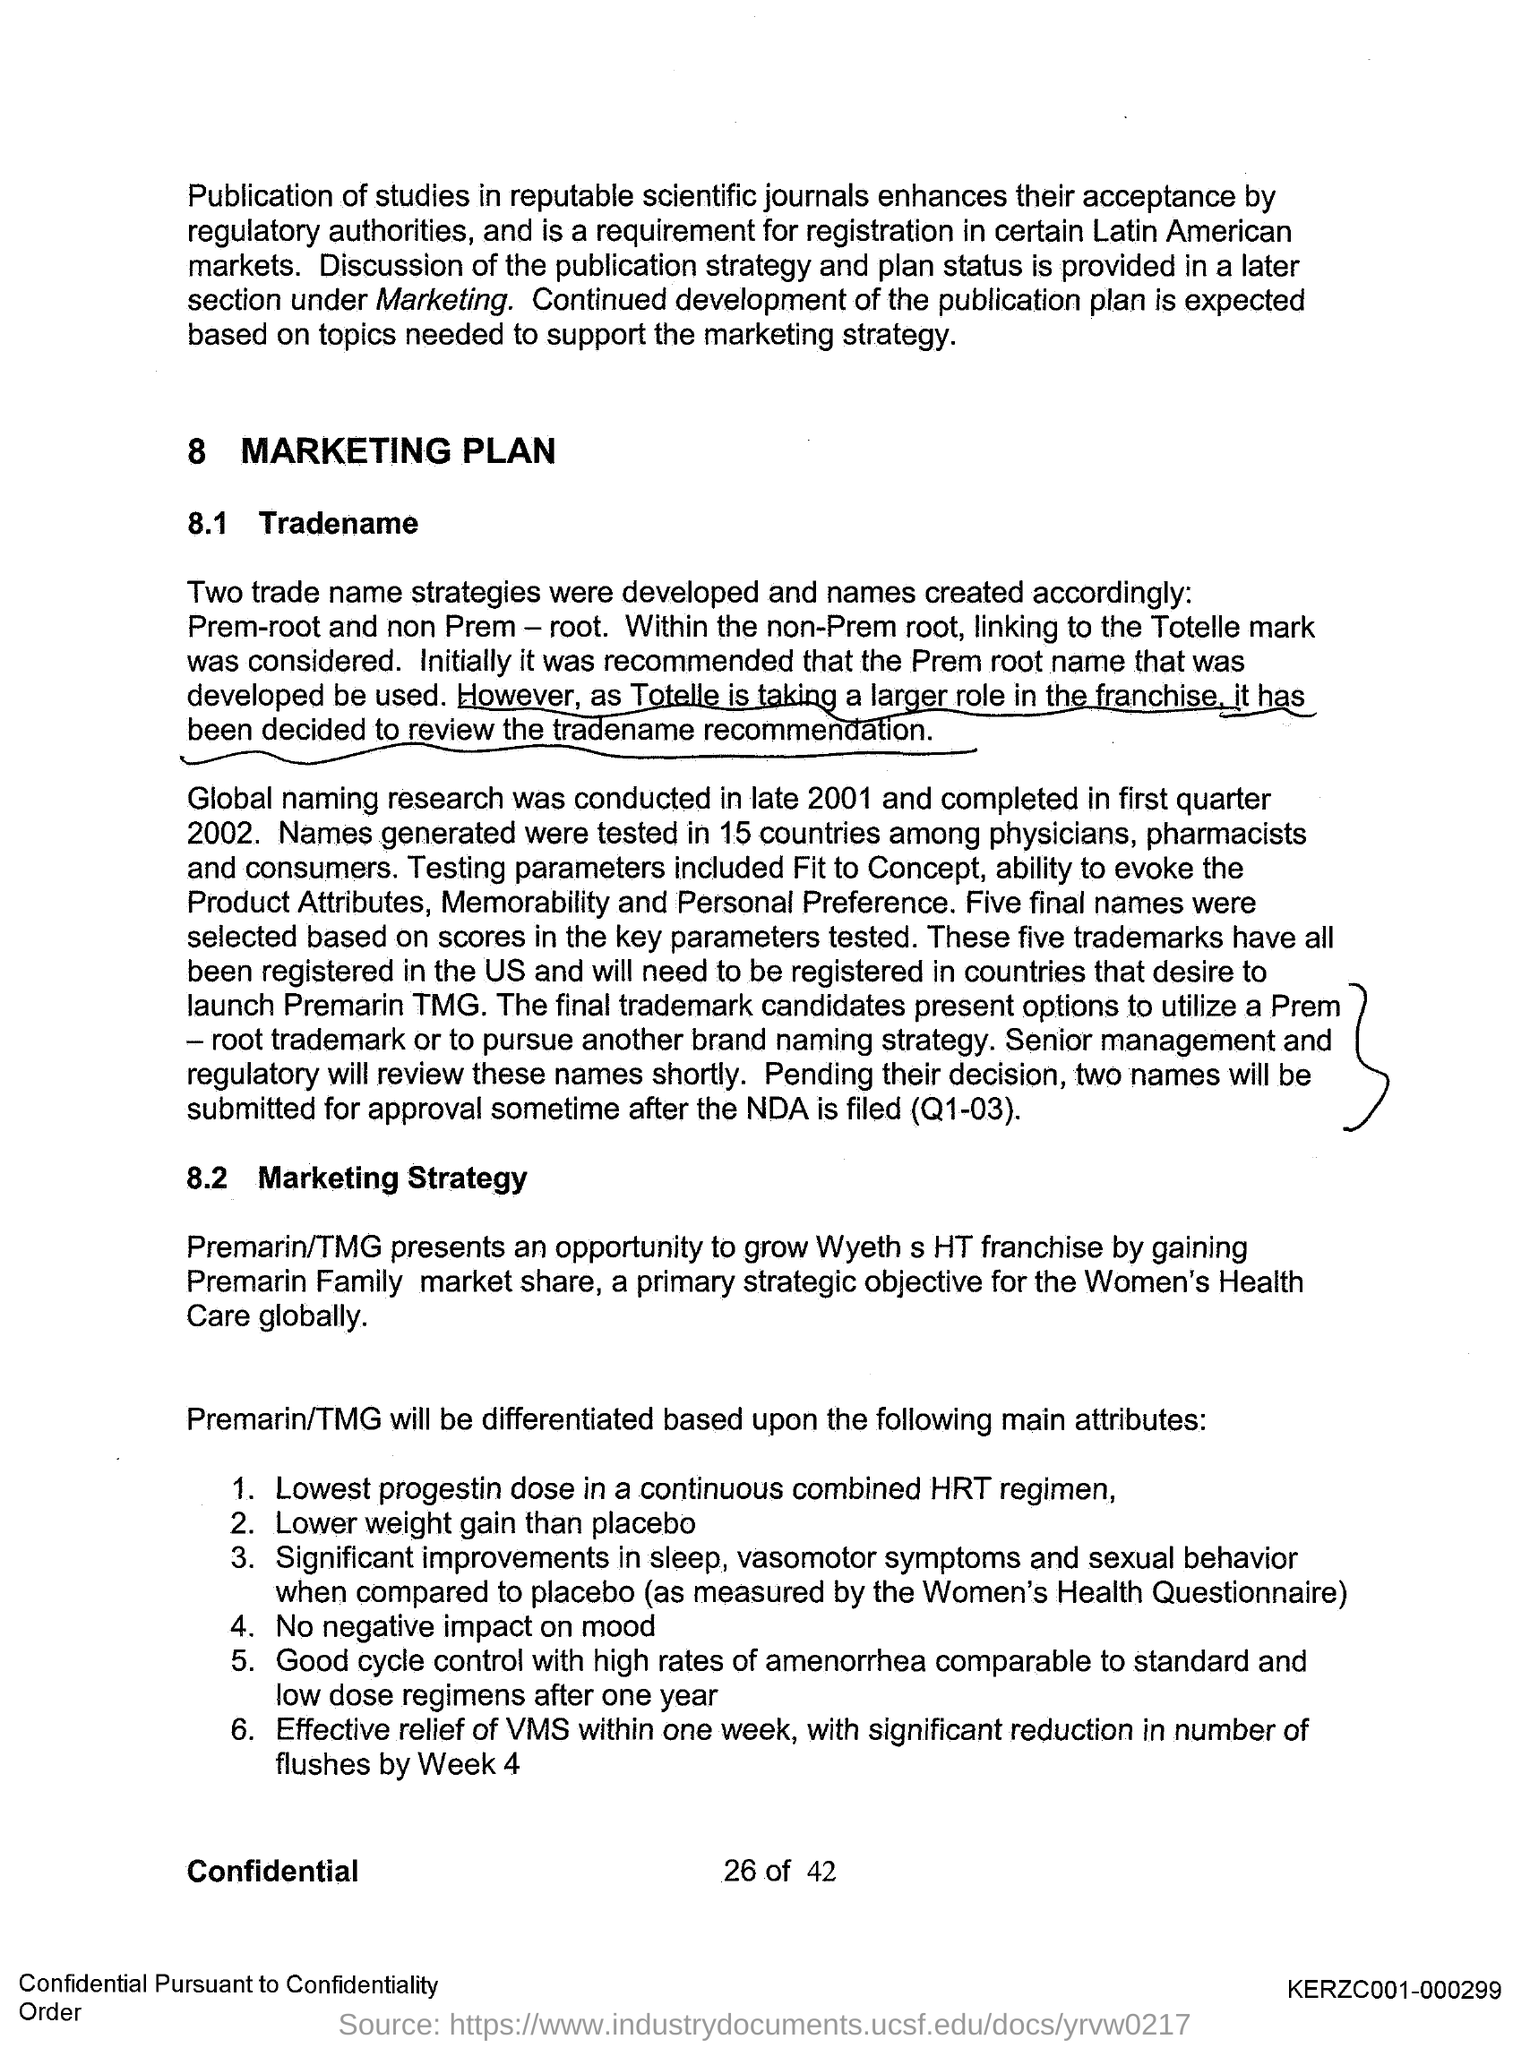Point out several critical features in this image. The third title in the document is 'Marketing Strategy.' The document's first title is 'Marketing Plan.' The second title in the document is "Tradename.. 